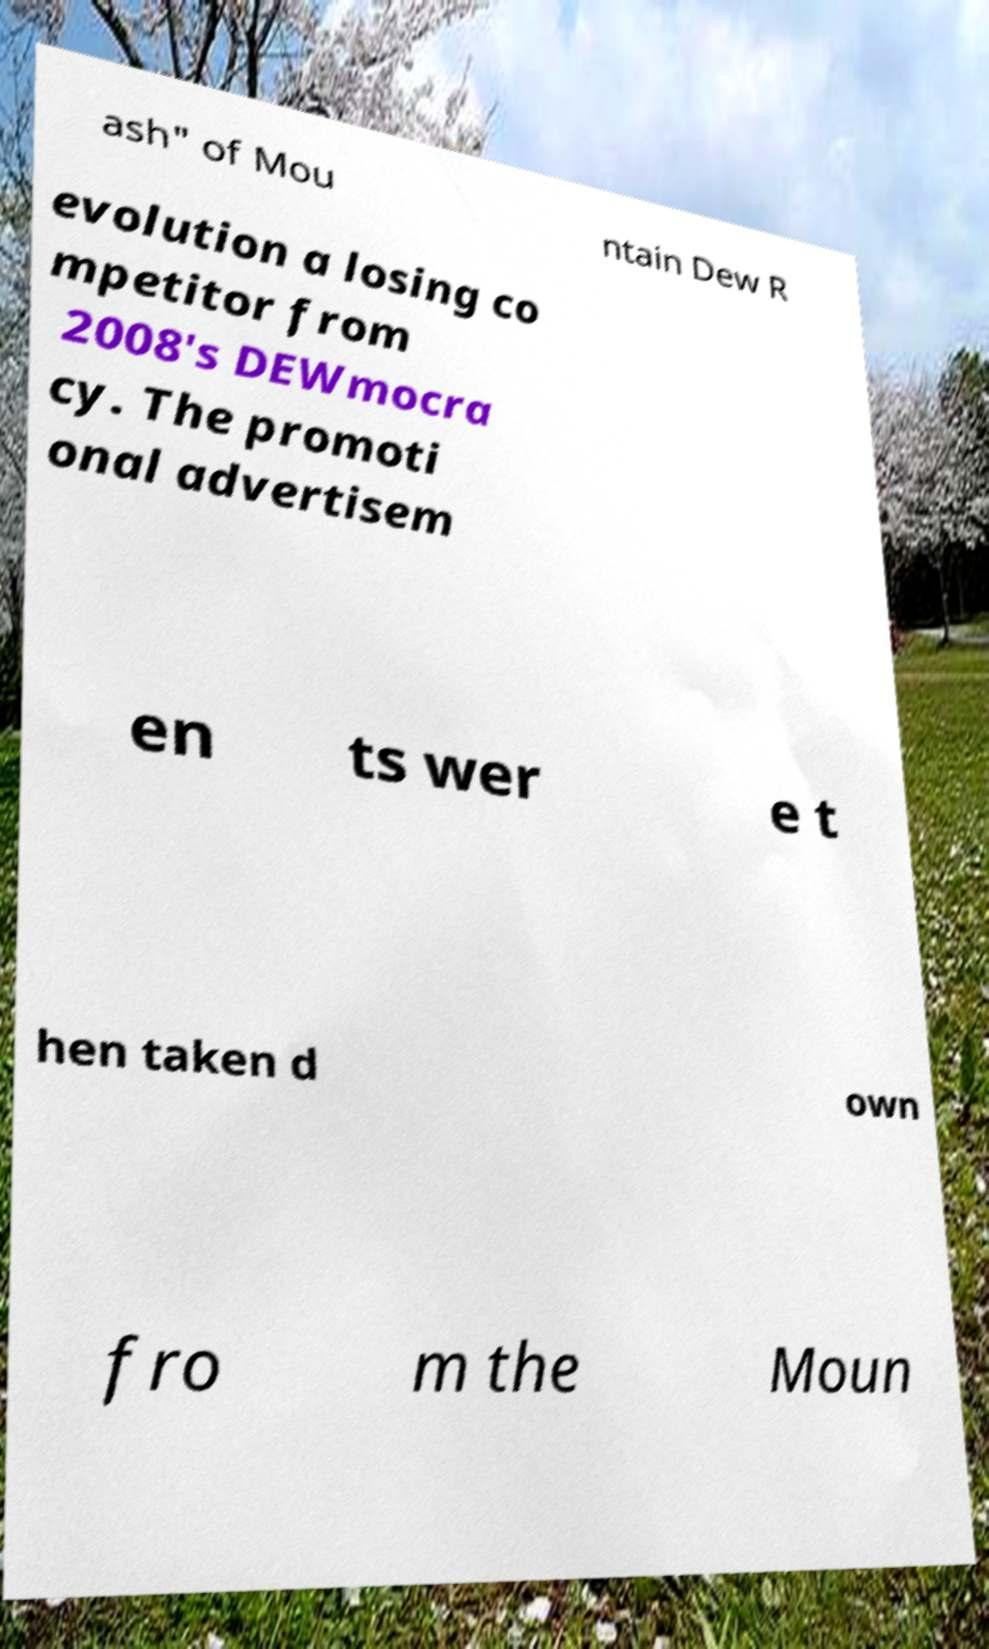For documentation purposes, I need the text within this image transcribed. Could you provide that? ash" of Mou ntain Dew R evolution a losing co mpetitor from 2008's DEWmocra cy. The promoti onal advertisem en ts wer e t hen taken d own fro m the Moun 